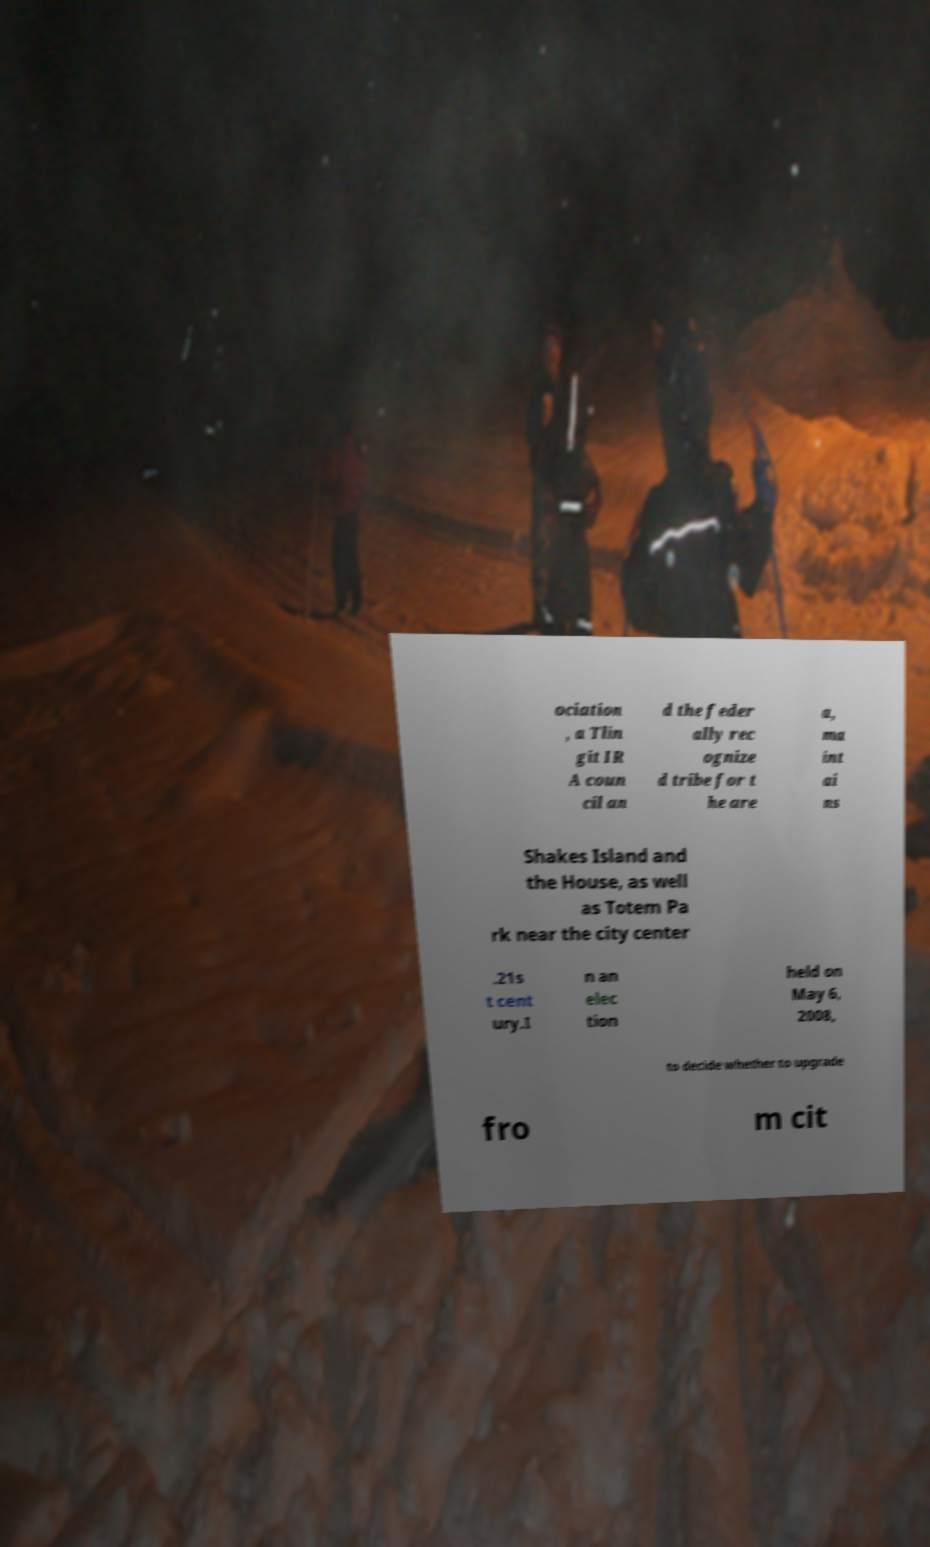Could you assist in decoding the text presented in this image and type it out clearly? ociation , a Tlin git IR A coun cil an d the feder ally rec ognize d tribe for t he are a, ma int ai ns Shakes Island and the House, as well as Totem Pa rk near the city center .21s t cent ury.I n an elec tion held on May 6, 2008, to decide whether to upgrade fro m cit 